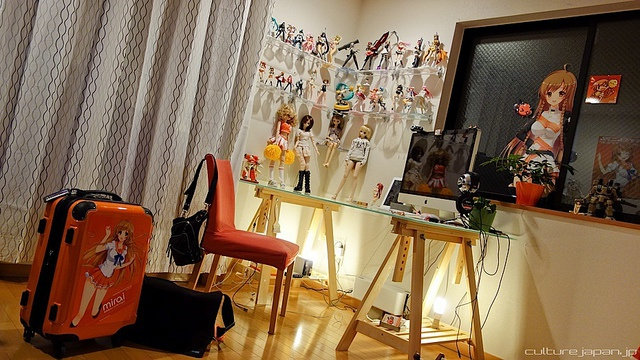Describe the objects in this image and their specific colors. I can see suitcase in darkgray, maroon, black, and brown tones, dining table in darkgray, olive, tan, and khaki tones, handbag in darkgray, black, maroon, and olive tones, chair in darkgray, maroon, red, black, and salmon tones, and tv in darkgray, black, maroon, and gray tones in this image. 